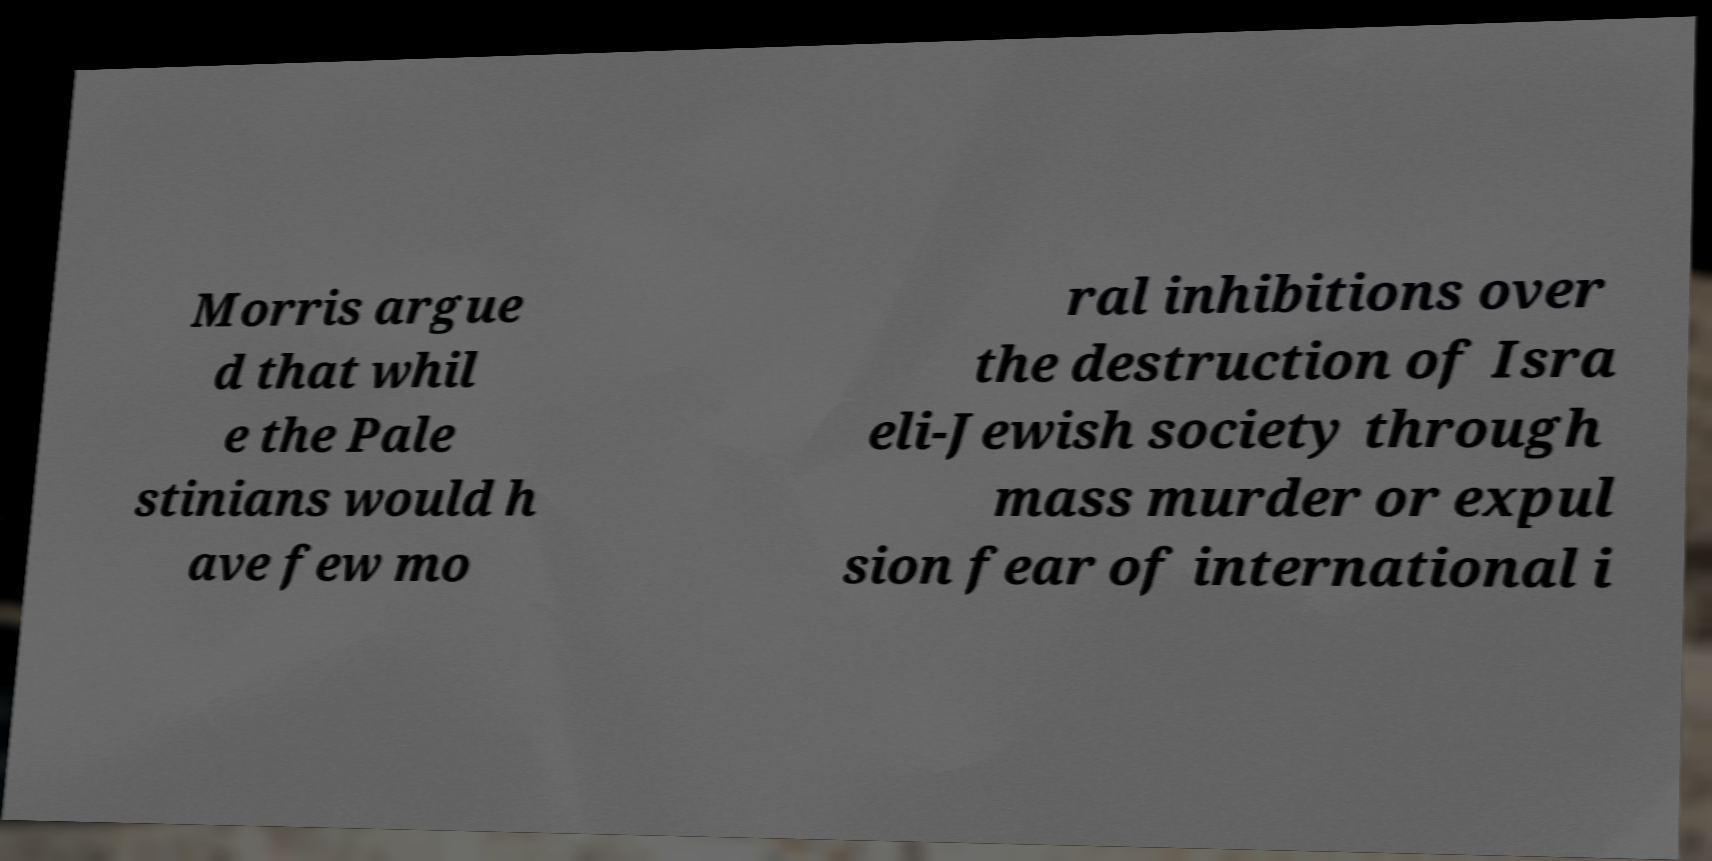Please read and relay the text visible in this image. What does it say? Morris argue d that whil e the Pale stinians would h ave few mo ral inhibitions over the destruction of Isra eli-Jewish society through mass murder or expul sion fear of international i 